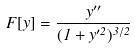Convert formula to latex. <formula><loc_0><loc_0><loc_500><loc_500>F [ y ] = \frac { y ^ { \prime \prime } } { ( 1 + y ^ { \prime 2 } ) ^ { 3 / 2 } }</formula> 